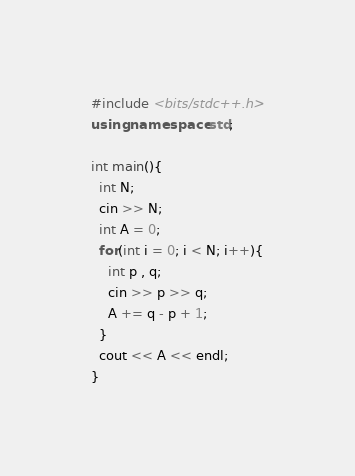Convert code to text. <code><loc_0><loc_0><loc_500><loc_500><_C++_>#include <bits/stdc++.h>
using namespace std;

int main(){
  int N;
  cin >> N;
  int A = 0;
  for(int i = 0; i < N; i++){
    int p , q;
    cin >> p >> q;
    A += q - p + 1;
  }
  cout << A << endl;
}
</code> 